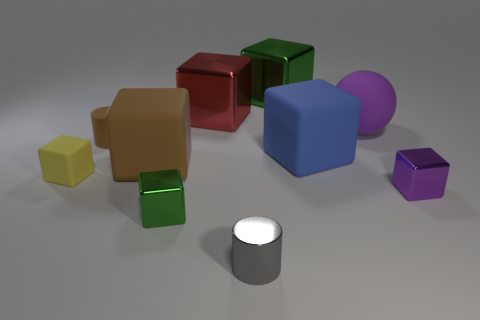There is a cylinder that is behind the tiny purple thing; what number of big purple rubber things are behind it? In the scene, there is one large purple cube positioned behind the small purple cube, giving the appearance of a single big purple object placed behind the tiny one. 